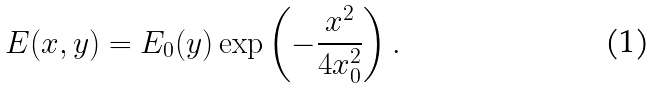<formula> <loc_0><loc_0><loc_500><loc_500>E ( x , y ) = E _ { 0 } ( y ) \exp \left ( - \frac { x ^ { 2 } } { 4 x _ { 0 } ^ { 2 } } \right ) .</formula> 